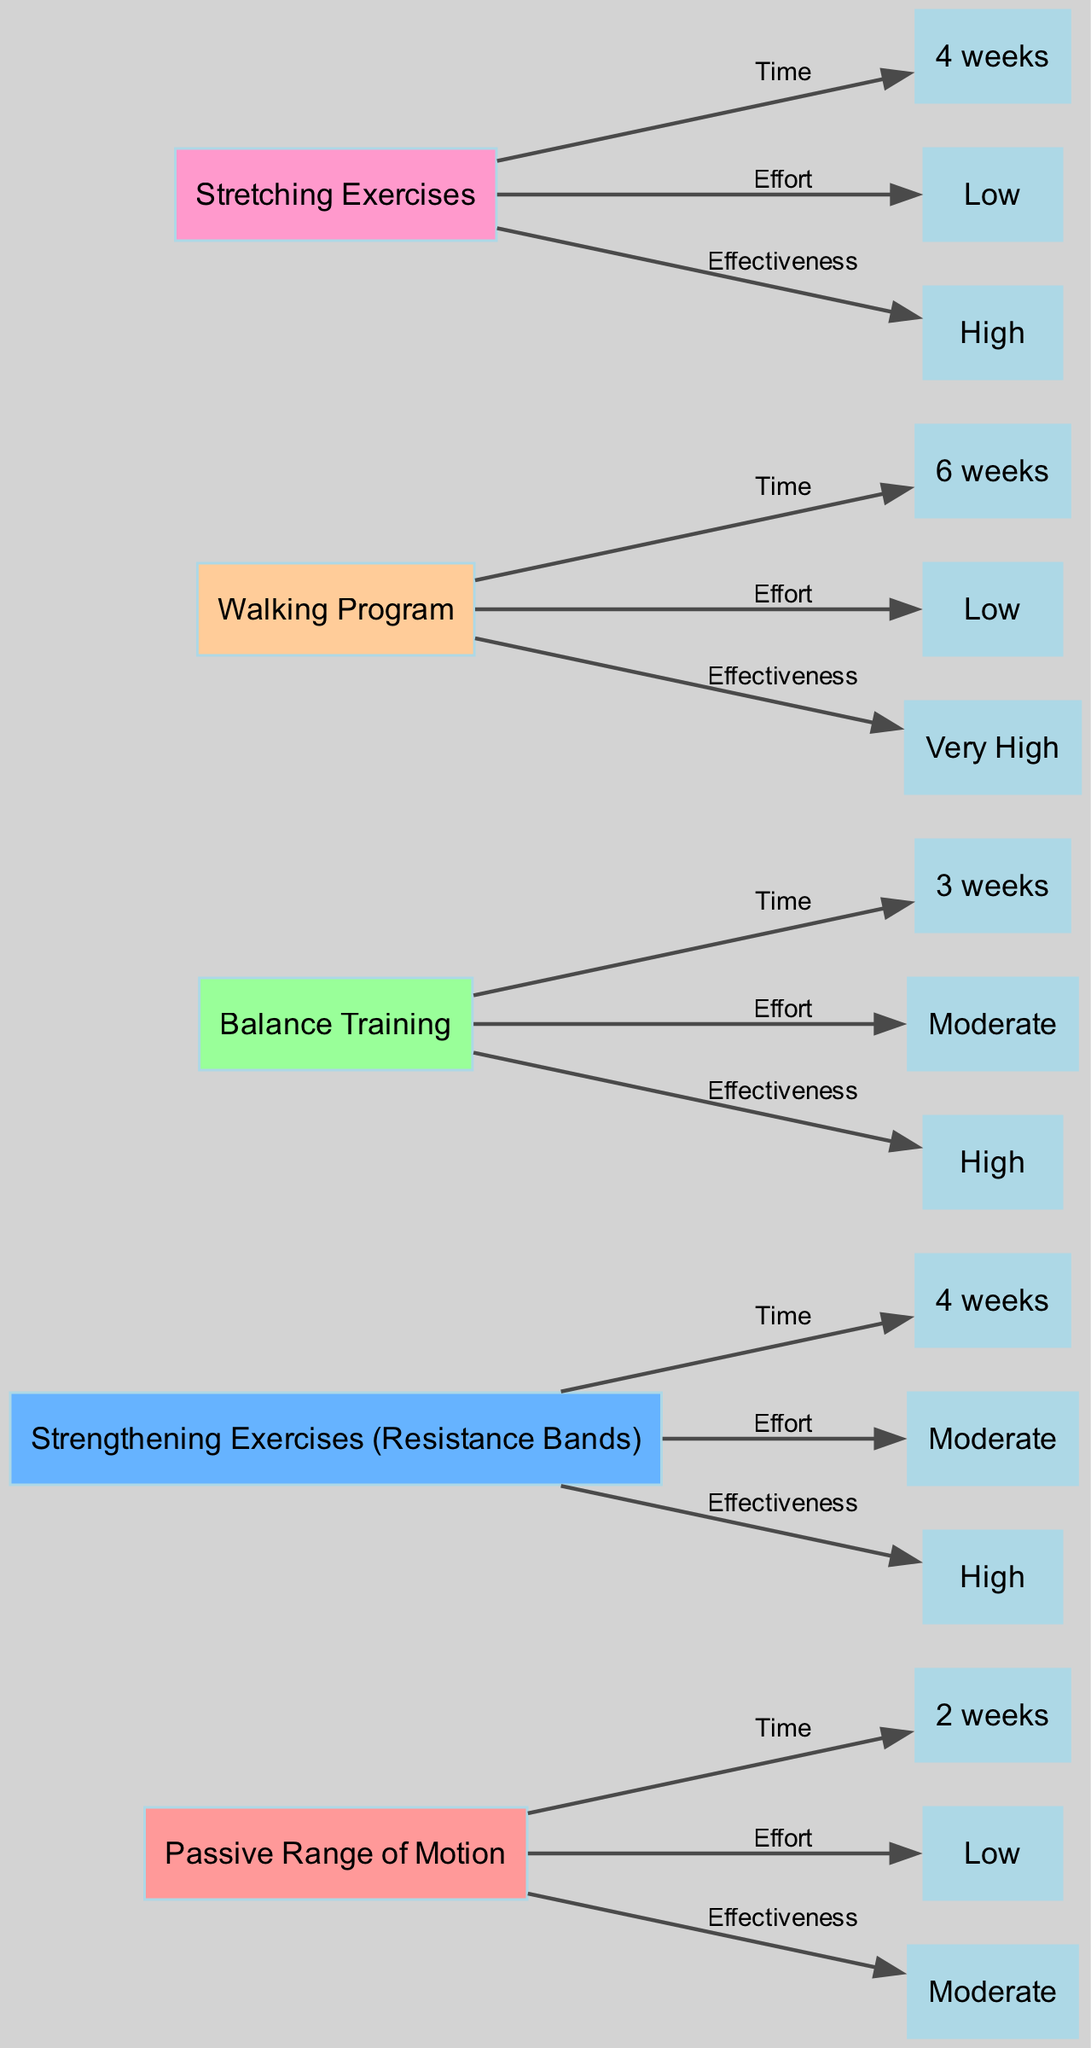What is the time allocated for the Walking Program? The diagram shows a label connected to the "Walking Program" node indicating "6 weeks" as the allocated time.
Answer: 6 weeks Which exercise has a low effort level? By looking at the effort level nodes, "Passive Range of Motion," "Walking Program," and "Stretching Exercises" all have "Low" indicated next to them.
Answer: Passive Range of Motion, Walking Program, Stretching Exercises What is the effectiveness of the Strengthening Exercises (Resistance Bands)? The diagram connects the "Strengthening Exercises (Resistance Bands)" node to an effectiveness node showing "High."
Answer: High Which exercise takes the longest amount of time to complete? By comparing the time allocations listed next to each exercise, "Walking Program" has the longest duration at "6 weeks."
Answer: Walking Program Which exercise has both moderate effort level and effectiveness? The diagram has the "Balance Training" node which is connected to both a "Moderate" effort level and "High" effectiveness node.
Answer: Balance Training How many exercises have high effectiveness? By analyzing the effectiveness indicators, "Strengthening Exercises (Resistance Bands)," "Balance Training," and "Stretching Exercises" fall under the "High" category, totaling three exercises.
Answer: 3 What is the effort level of the Stretching Exercises? This can be determined by tracing the edge connected to the "Stretching Exercises" node, where it indicates "Low" as the effort level.
Answer: Low Which rehabilitation exercise is perceived as having very high effectiveness? The exercise node labeled "Walking Program" has a direct connection to "Very High" under effectiveness in the diagram.
Answer: Walking Program What connection is established between the "Passive Range of Motion" and its effectiveness? The diagram shows that "Passive Range of Motion" connects to a node labeled "Moderate" indicating its perceived effectiveness.
Answer: Moderate 